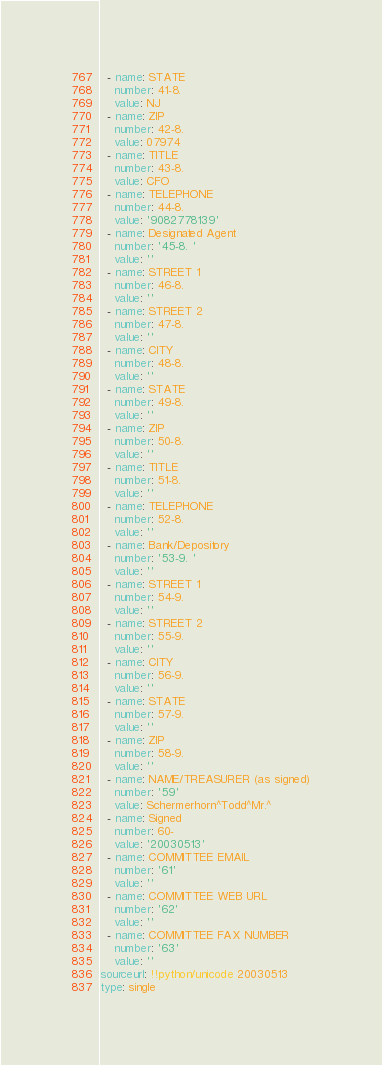<code> <loc_0><loc_0><loc_500><loc_500><_YAML_>  - name: STATE
    number: 41-8.
    value: NJ
  - name: ZIP
    number: 42-8.
    value: 07974
  - name: TITLE
    number: 43-8.
    value: CFO
  - name: TELEPHONE
    number: 44-8.
    value: '9082778139'
  - name: Designated Agent
    number: '45-8. '
    value: ''
  - name: STREET 1
    number: 46-8.
    value: ''
  - name: STREET 2
    number: 47-8.
    value: ''
  - name: CITY
    number: 48-8.
    value: ''
  - name: STATE
    number: 49-8.
    value: ''
  - name: ZIP
    number: 50-8.
    value: ''
  - name: TITLE
    number: 51-8.
    value: ''
  - name: TELEPHONE
    number: 52-8.
    value: ''
  - name: Bank/Depository
    number: '53-9. '
    value: ''
  - name: STREET 1
    number: 54-9.
    value: ''
  - name: STREET 2
    number: 55-9.
    value: ''
  - name: CITY
    number: 56-9.
    value: ''
  - name: STATE
    number: 57-9.
    value: ''
  - name: ZIP
    number: 58-9.
    value: ''
  - name: NAME/TREASURER (as signed)
    number: '59'
    value: Schermerhorn^Todd^Mr.^
  - name: Signed
    number: 60-
    value: '20030513'
  - name: COMMITTEE EMAIL
    number: '61'
    value: ''
  - name: COMMITTEE WEB URL
    number: '62'
    value: ''
  - name: COMMITTEE FAX NUMBER
    number: '63'
    value: ''
sourceurl: !!python/unicode 20030513
type: single
</code> 